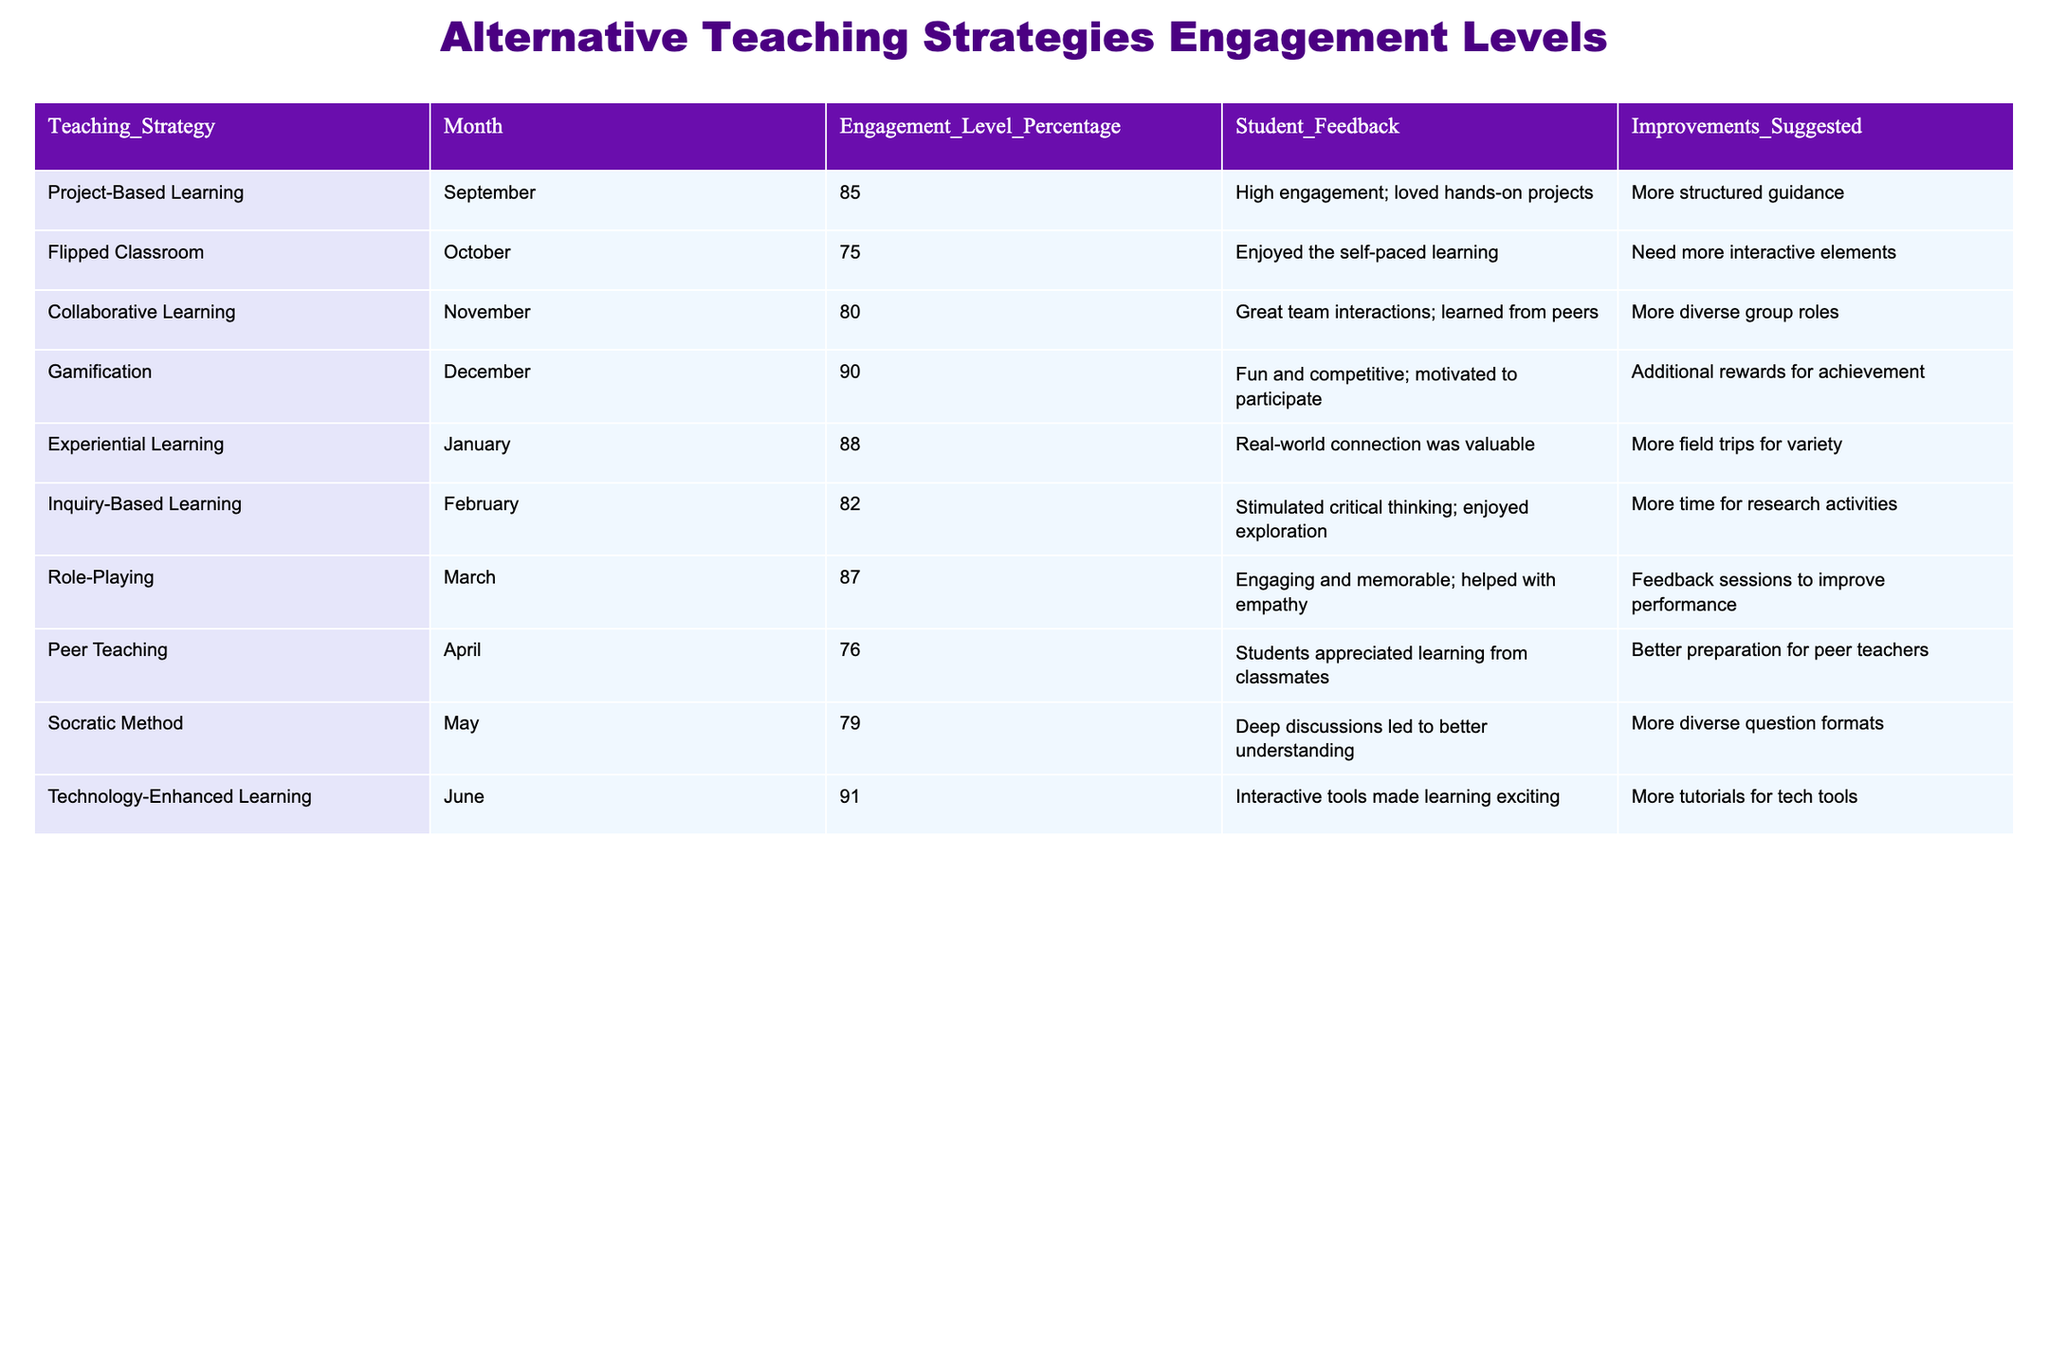What was the engagement level during Gamification in December? The engagement level for Gamification in December is directly stated in the table as 90%.
Answer: 90% Which teaching strategy had the highest engagement level, and what was that level? By examining the table, we see that Gamification has the highest engagement level at 90%.
Answer: Gamification, 90% What improvements were suggested for Project-Based Learning based on student feedback? The table indicates that students suggested "More structured guidance" for Project-Based Learning.
Answer: More structured guidance What was the average engagement level from September to December? Collectively adding the engagement levels for September (85), October (75), November (80), and December (90) gives us a total of 330. Dividing by 4 (the number of months) results in an average of 82.5.
Answer: 82.5 Is it true that the engagement level for Inquiry-Based Learning in February was lower than for Role-Playing in March? Consulting the table, Inquiry-Based Learning had an engagement level of 82 in February, while Role-Playing had 87 in March. Thus, this statement is true.
Answer: True What suggestions were made for improvements for Peer Teaching and Collaborate Learning? The table indicates that Peer Teaching suggested "Better preparation for peer teachers" while Collaborative Learning suggested "More diverse group roles."
Answer: Better preparation for peer teachers; More diverse group roles If we consider the engagement levels from January to June, what is the total increase from January (Experiential Learning) to June (Technology-Enhanced Learning)? The engagement level for Experiential Learning in January is 88 and in June it is 91. The increase is 91 - 88 = 3.
Answer: 3 How many strategies received feedback that included the need for more interactive elements? From the table, only two strategies—Flipped Classroom in October and Technology-Enhanced Learning in June—received feedback indicating the need for more interactive elements.
Answer: 2 What is the median engagement level of all the teaching strategies presented in the table? There are ten engagement levels: 85, 75, 80, 90, 88, 82, 87, 76, 79, and 91. When arranged in order, the values are: 75, 76, 79, 80, 82, 85, 87, 88, 90, 91. The median is the average of the 5th and 6th values: (82 + 85) / 2 = 83.5.
Answer: 83.5 